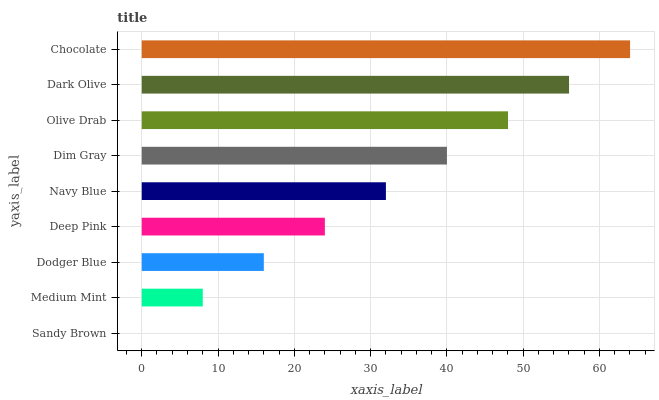Is Sandy Brown the minimum?
Answer yes or no. Yes. Is Chocolate the maximum?
Answer yes or no. Yes. Is Medium Mint the minimum?
Answer yes or no. No. Is Medium Mint the maximum?
Answer yes or no. No. Is Medium Mint greater than Sandy Brown?
Answer yes or no. Yes. Is Sandy Brown less than Medium Mint?
Answer yes or no. Yes. Is Sandy Brown greater than Medium Mint?
Answer yes or no. No. Is Medium Mint less than Sandy Brown?
Answer yes or no. No. Is Navy Blue the high median?
Answer yes or no. Yes. Is Navy Blue the low median?
Answer yes or no. Yes. Is Dodger Blue the high median?
Answer yes or no. No. Is Deep Pink the low median?
Answer yes or no. No. 